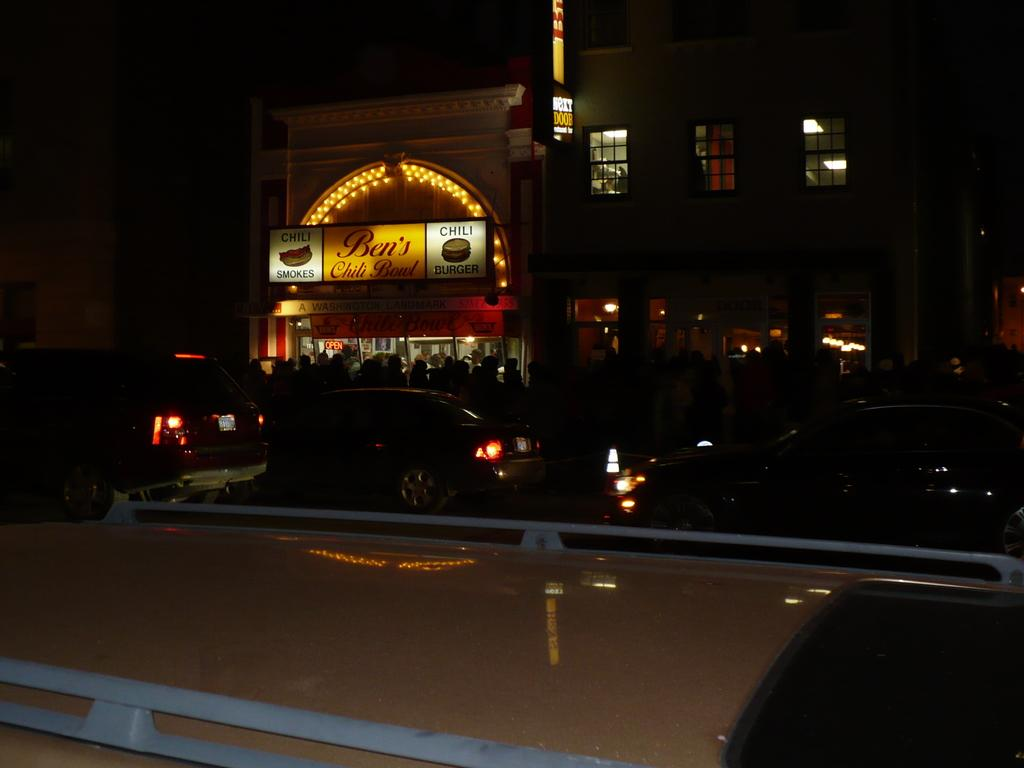What type of structures can be seen in the image? There are buildings in the image. What objects are present in addition to the buildings? There are boards and vehicles in the image. What is written on the boards? There is writing on the boards. Can you describe the lighting conditions in the image? The image appears to be in a dark setting. What is the tendency of the wave in the image? There is no wave present in the image. How much debt is visible in the image? There is no debt visible in the image. 